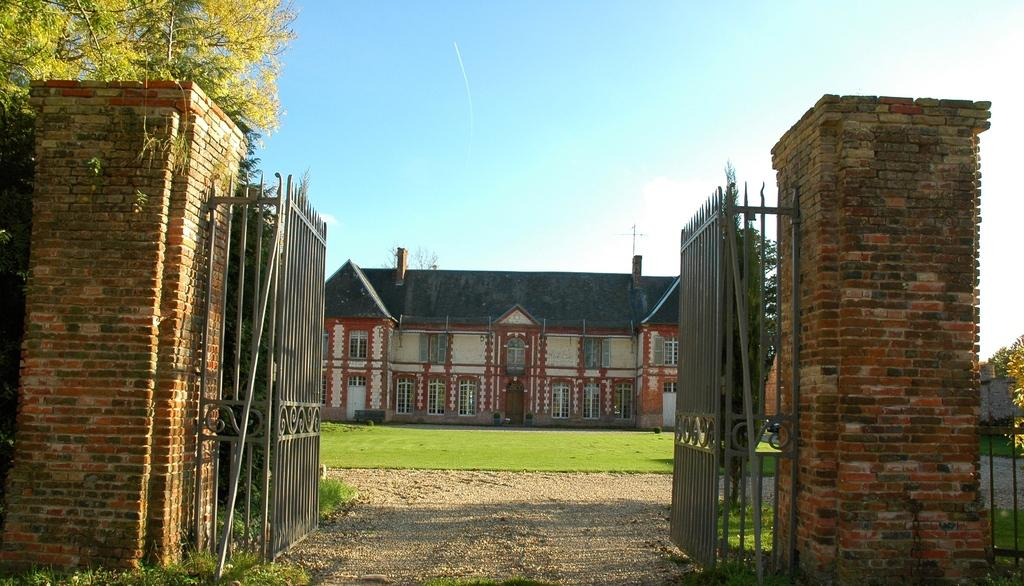What structure can be seen in the image? There is a gate in the image. What else is present in the image besides the gate? There is a building and trees in the image. What can be seen in the background of the image? The sky is visible in the background of the image. What type of fiction is being read by the lawyer in the image? There is no lawyer or fiction present in the image; it only features a gate, a building, trees, and the sky. 